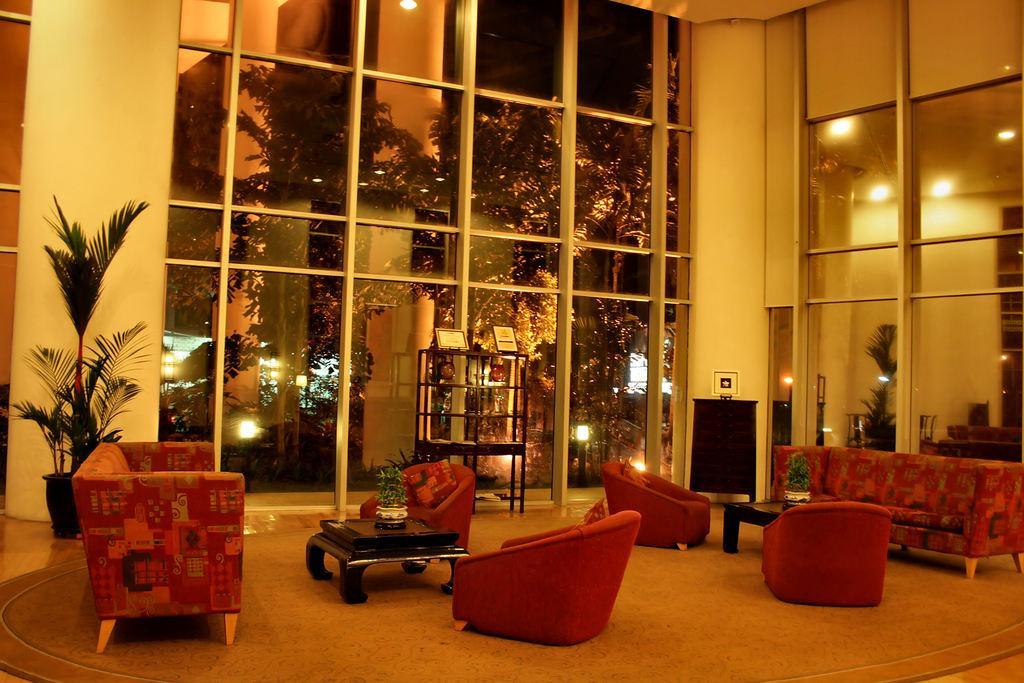How would you summarize this image in a sentence or two? In this picture we can see two couches are there and some chairs in between them there is a table on the table we have flower-was back side we can see the glass window can see the outside of of it there so many trees outside in the room there is a one potted plant 